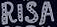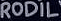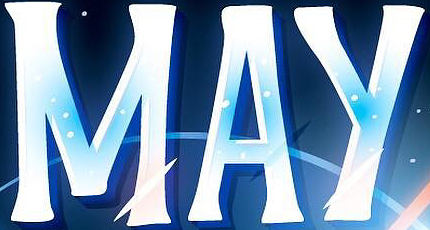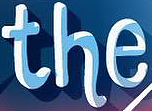Identify the words shown in these images in order, separated by a semicolon. RISA; RODIL; MAY; the 